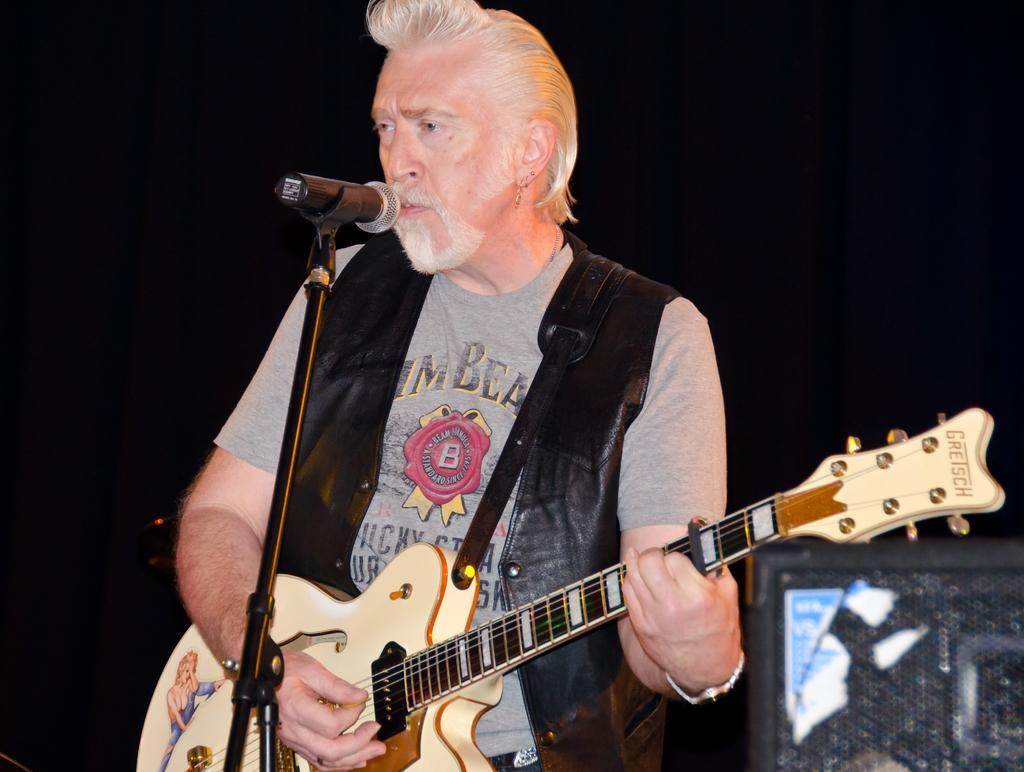What is the main subject of the image? There is a person in the image. What is the person wearing? The person is wearing a black color jacket. What activity is the person engaged in? The person is playing a guitar. What object is in front of the person? There is a microphone in front of the person. How many jellyfish can be seen in the bedroom in the image? There is no bedroom or jellyfish present in the image. 